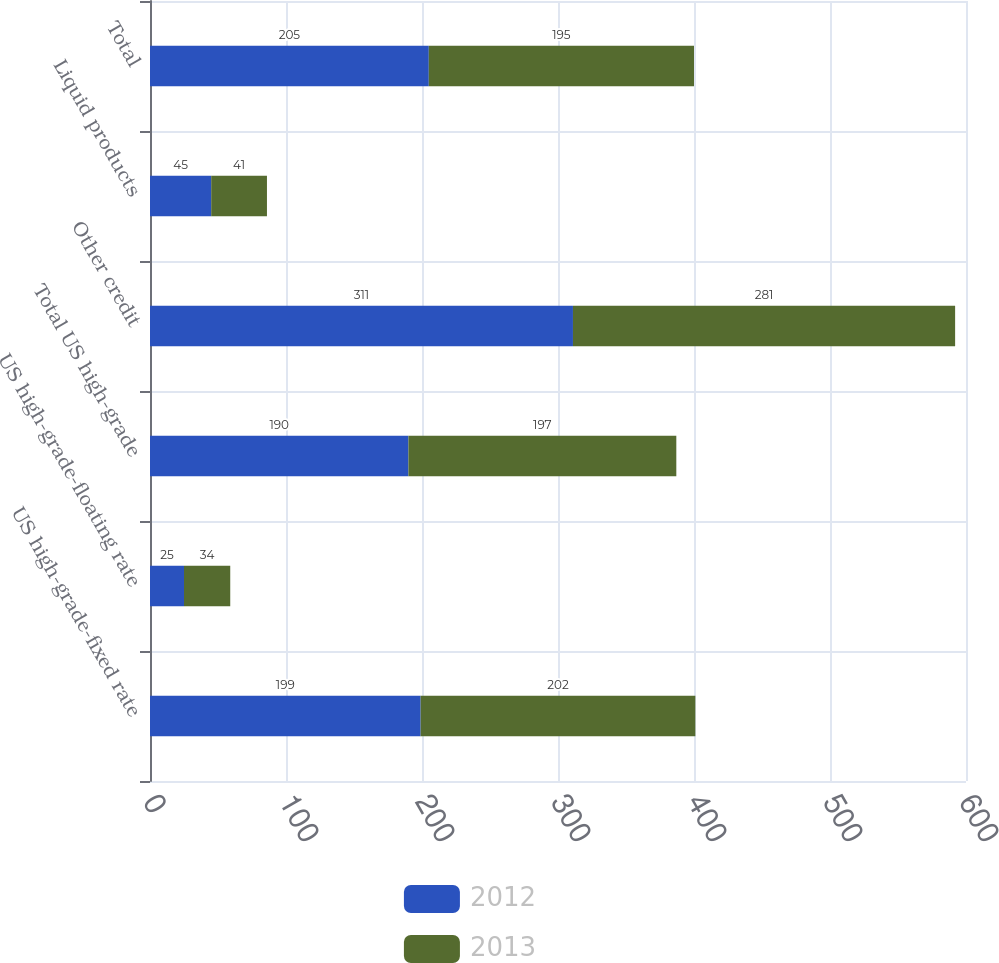Convert chart. <chart><loc_0><loc_0><loc_500><loc_500><stacked_bar_chart><ecel><fcel>US high-grade-fixed rate<fcel>US high-grade-floating rate<fcel>Total US high-grade<fcel>Other credit<fcel>Liquid products<fcel>Total<nl><fcel>2012<fcel>199<fcel>25<fcel>190<fcel>311<fcel>45<fcel>205<nl><fcel>2013<fcel>202<fcel>34<fcel>197<fcel>281<fcel>41<fcel>195<nl></chart> 